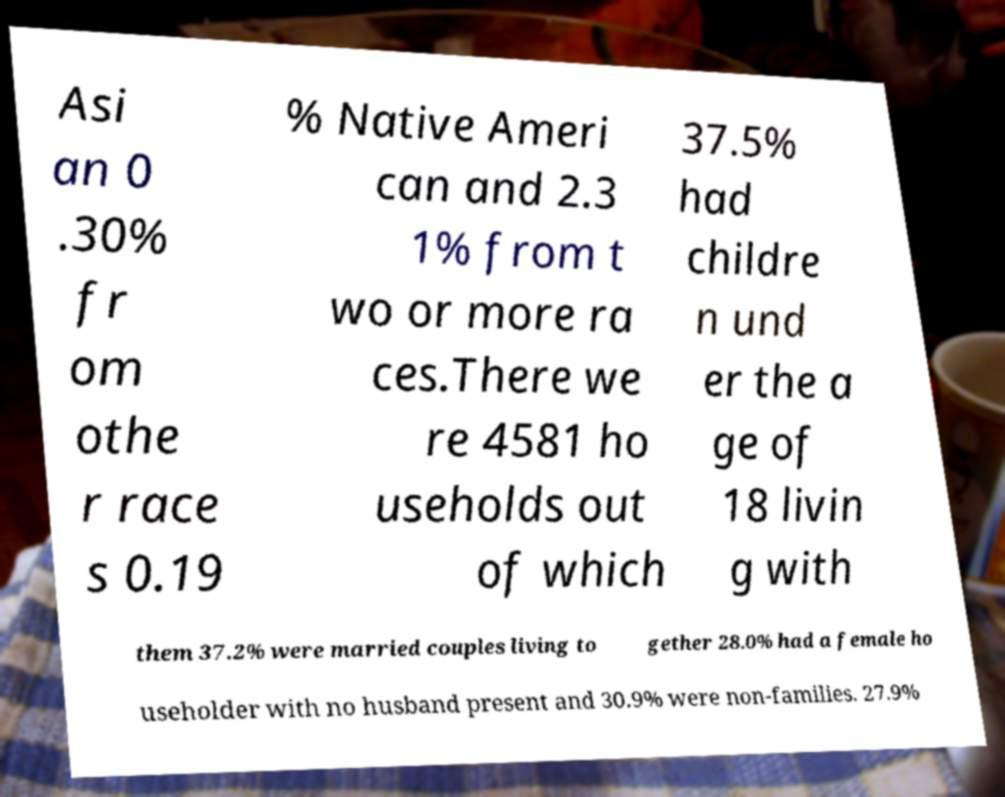Could you extract and type out the text from this image? Asi an 0 .30% fr om othe r race s 0.19 % Native Ameri can and 2.3 1% from t wo or more ra ces.There we re 4581 ho useholds out of which 37.5% had childre n und er the a ge of 18 livin g with them 37.2% were married couples living to gether 28.0% had a female ho useholder with no husband present and 30.9% were non-families. 27.9% 